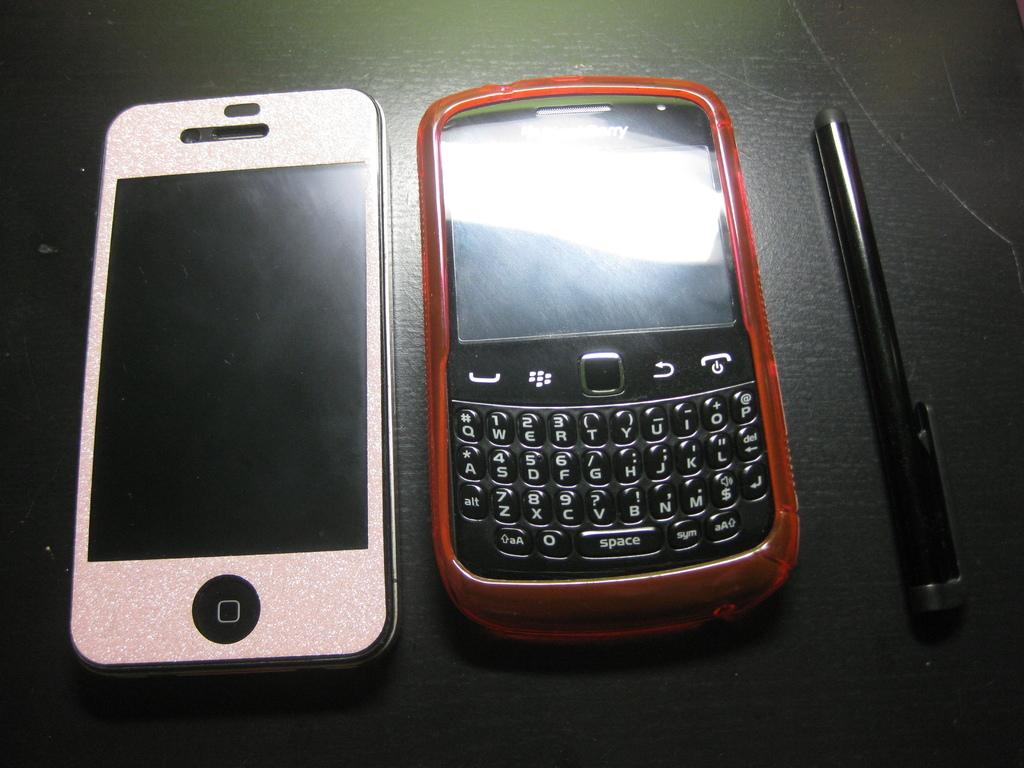What types of objects are present in the image? There are two electronic devices and a pen in the image. What might be used for writing or drawing in the image? The pen in the image can be used for writing or drawing. Where are the electronic devices and pen located in the image? The electronic devices and pen are on a solid surface in the image. Can you see any goldfish swimming in the image? No, there are no goldfish present in the image. What type of business is being conducted in the image? The image does not depict any business activities or settings, so it is not possible to determine the type of business being conducted. 